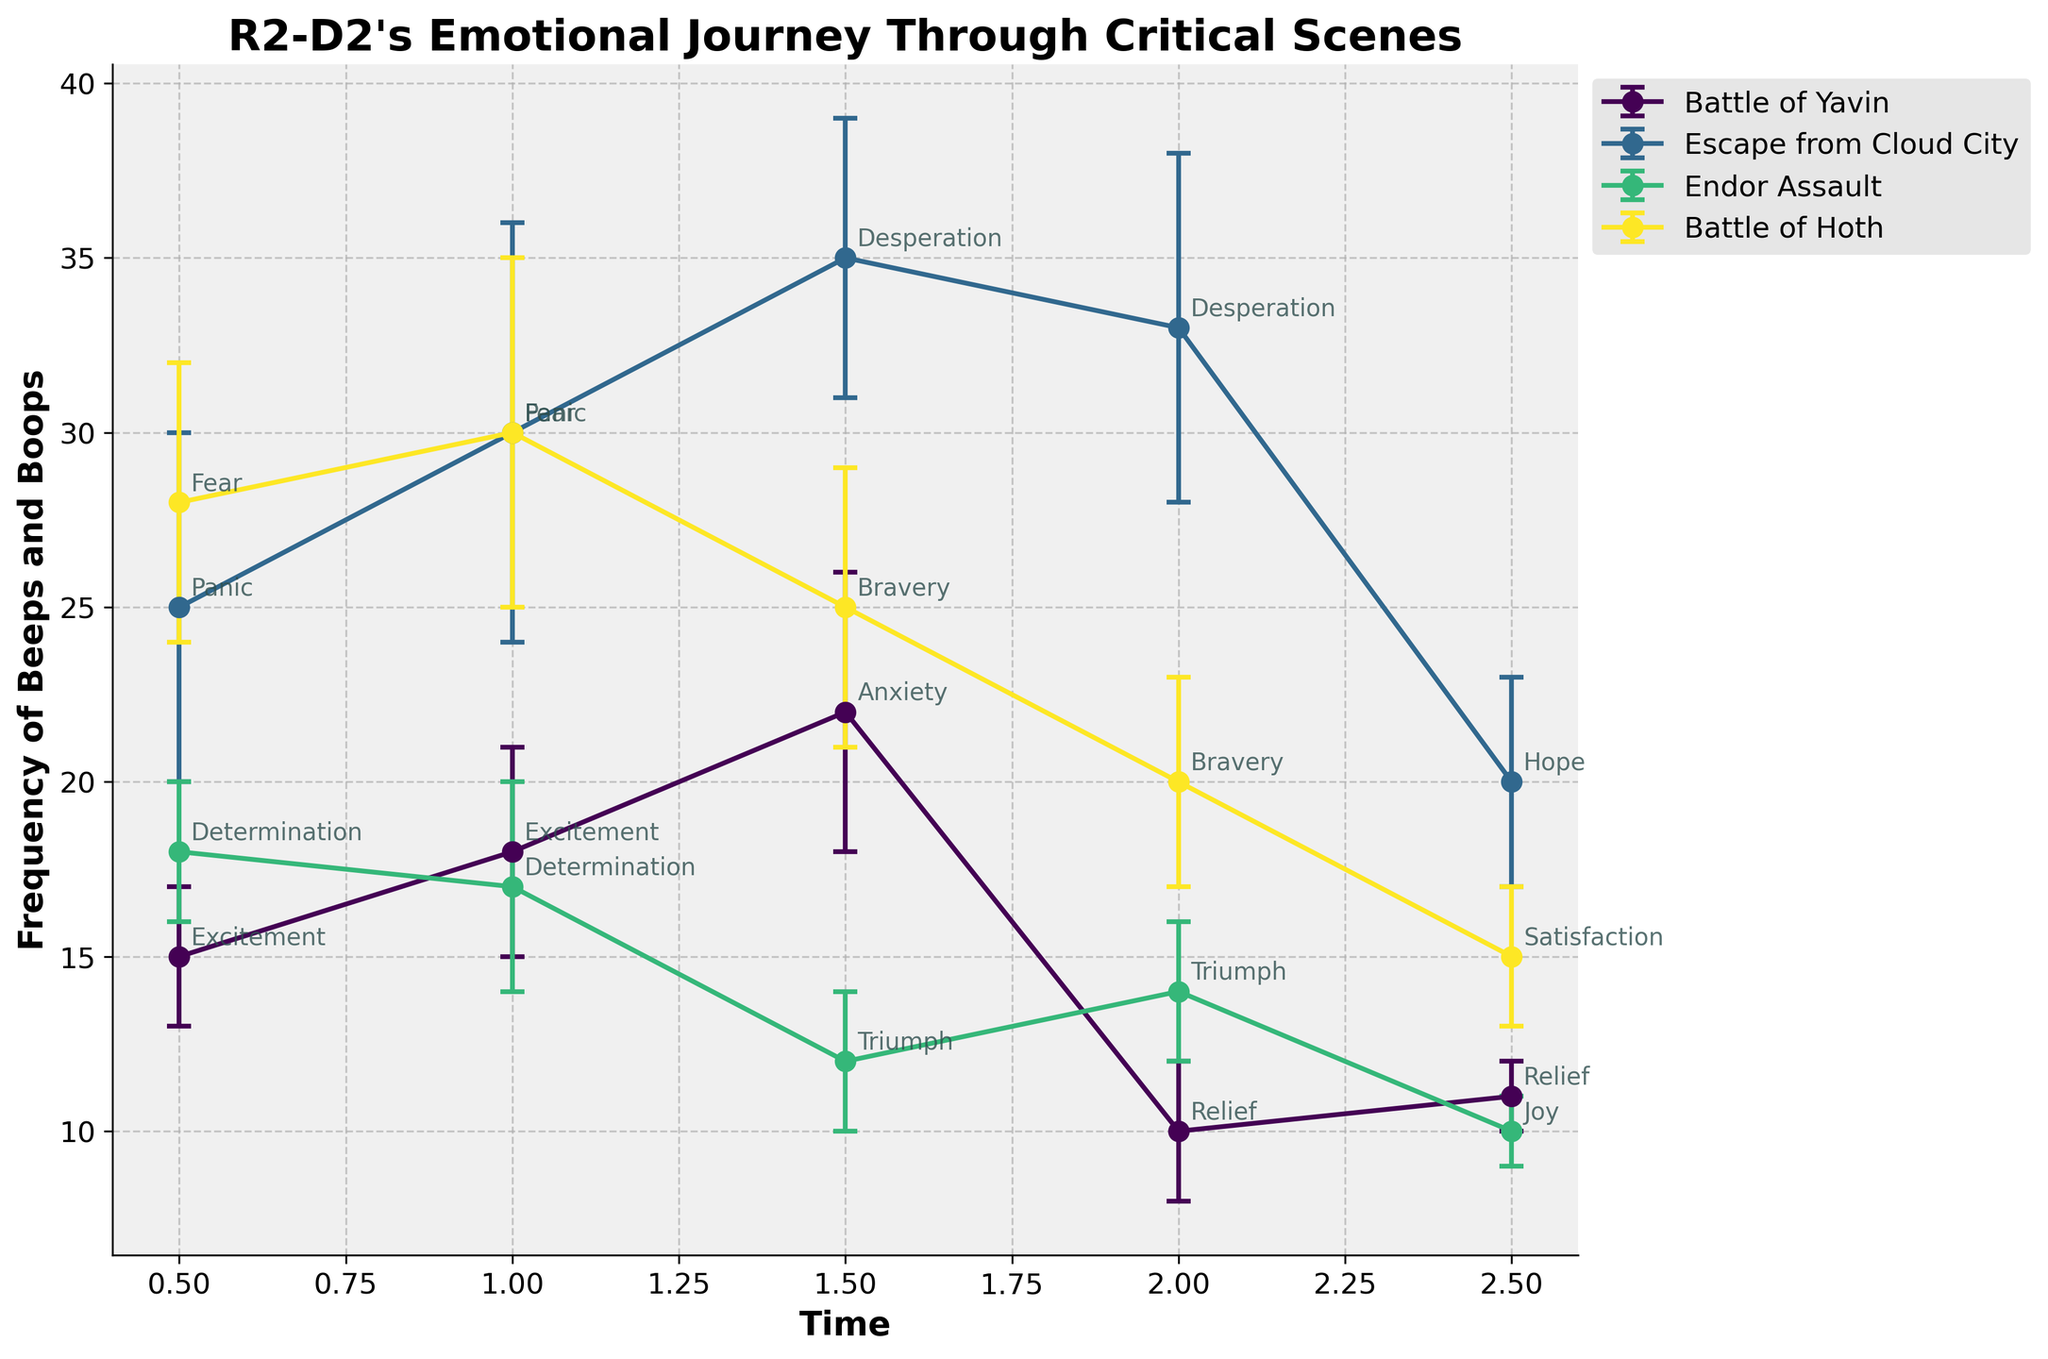what is the title of the figure? The title of the figure is shown at the top center of the chart. It reads "R2-D2's Emotional Journey Through Critical Scenes."
Answer: R2-D2's Emotional Journey Through Critical Scenes Which scene has the highest frequency of beeps and boops recorded? By observing the highest point on the line plot, the "Escape from Cloud City" scene at time 1.5 minutes has the highest frequency of 35 beeps and boops.
Answer: Escape from Cloud City At which time point does R2-D2 show the emotion 'Triumph' during the Endor Assault? The data point labeled 'Triumph' during the Endor Assault is at time 1.5 minutes.
Answer: 1.5 minutes What is the difference in R2-D2's frequency of beeps and boops between 'Excitement' at time 1.0 and 'Relief' at time 2.0 during the Battle of Yavin? The frequency for 'Excitement' at time 1.0 is 18, and for 'Relief' at time 2.0 is 10. The difference is calculated as 18 - 10.
Answer: 8 Which scenes show a decrease in the frequency of beeps and boops over time? By observing the trend in the curves, the scenes with a noticeable decrease over time are "Battle of Hoth" and "Endor Assault."
Answer: Battle of Hoth and Endor Assault What emotion is associated with the peak frequency of beeps and boops during the Battle of Yavin? The peak frequency during the Battle of Yavin is 22 beeps and boops, which is associated with the emotion 'Anxiety' at time 1.5 minutes.
Answer: Anxiety How does the frequency of beeps and boops change as R2-D2's emotion shifts from 'Panic' to 'Hope' during the Escape from Cloud City? The frequency starts at 25 (Panic at 0.5 minutes), reaches up to 35 (Desperation at 1.5 minutes), and then drops to 20 (Hope at 2.5 minutes). So, it increases first and then decreases.
Answer: First increases then decreases 